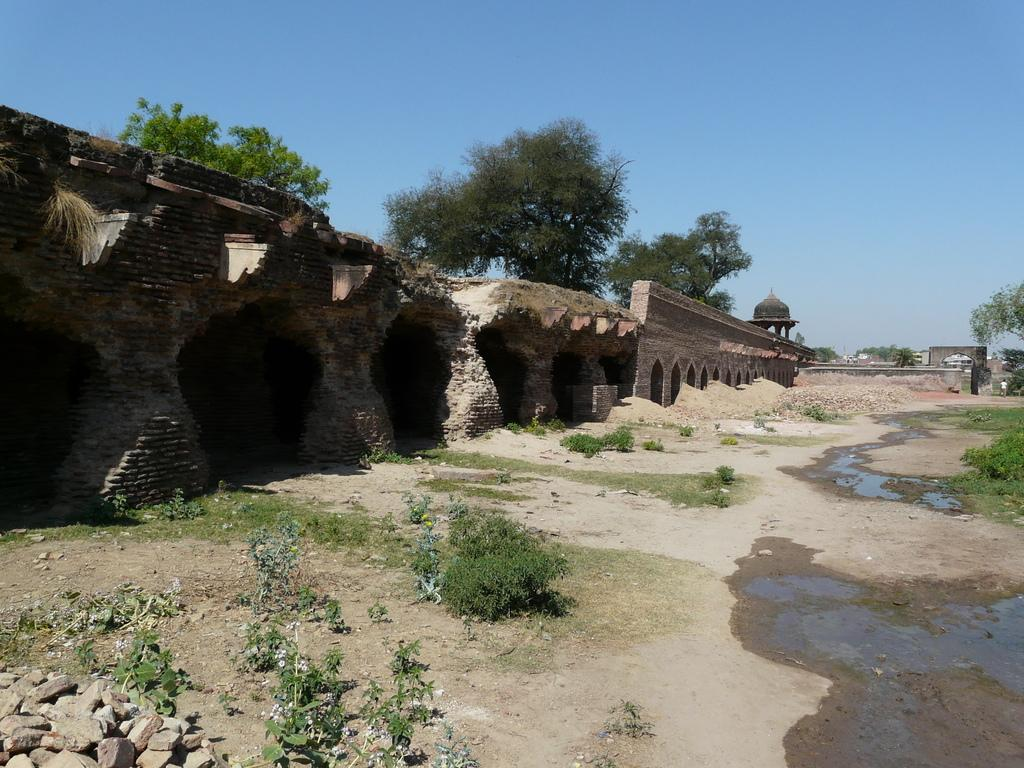What type of structure is visible in the image? There is a fort in the image. What is the condition of the fort? The fort is damaged. What other natural elements can be seen in the image? There are plants, rocks, and water on the surface visible in the image. What is visible in the background of the image? There are trees and the sky visible in the background of the image. What is the rate at which the orange is growing in the image? There is no orange present in the image, so it is not possible to determine the rate at which it might be growing. 